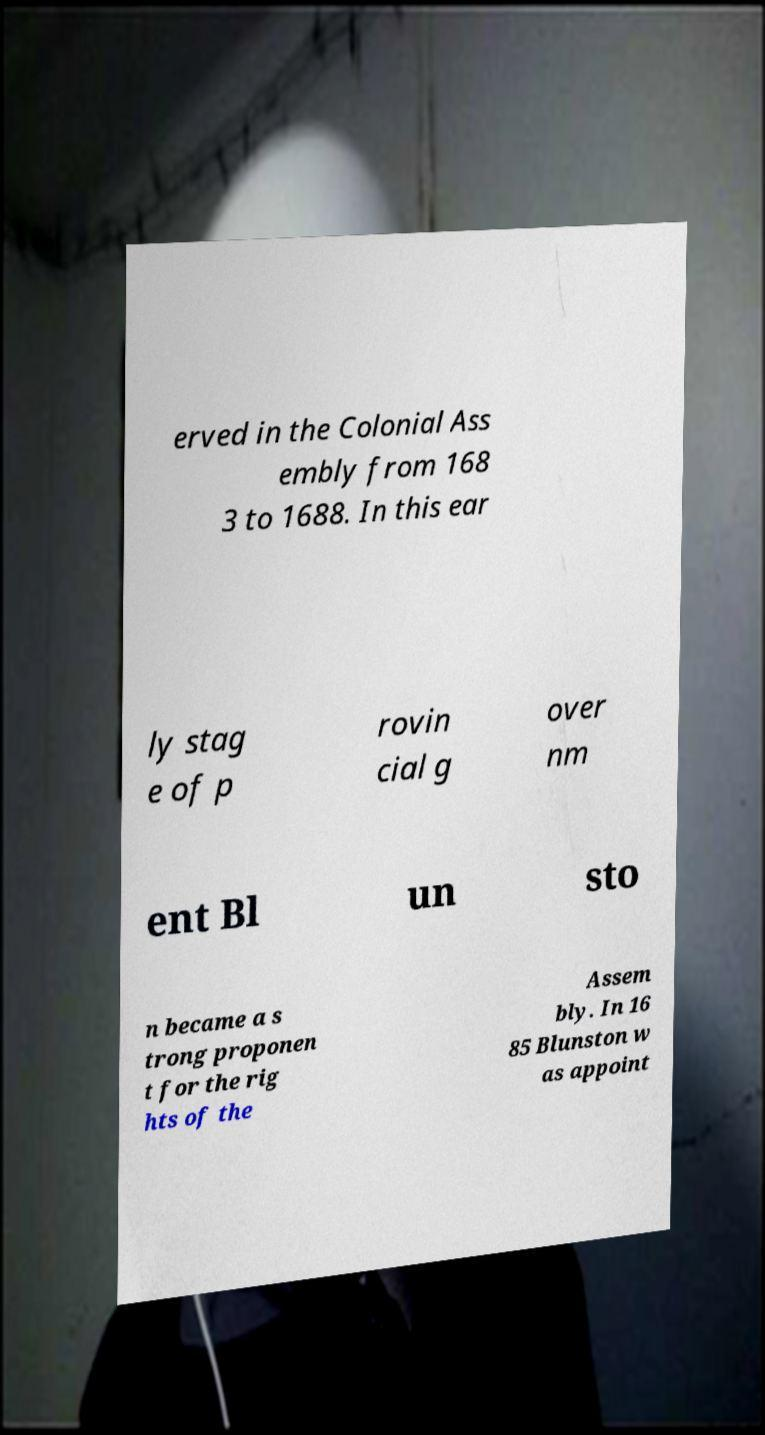Please identify and transcribe the text found in this image. erved in the Colonial Ass embly from 168 3 to 1688. In this ear ly stag e of p rovin cial g over nm ent Bl un sto n became a s trong proponen t for the rig hts of the Assem bly. In 16 85 Blunston w as appoint 